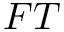<formula> <loc_0><loc_0><loc_500><loc_500>F T</formula> 